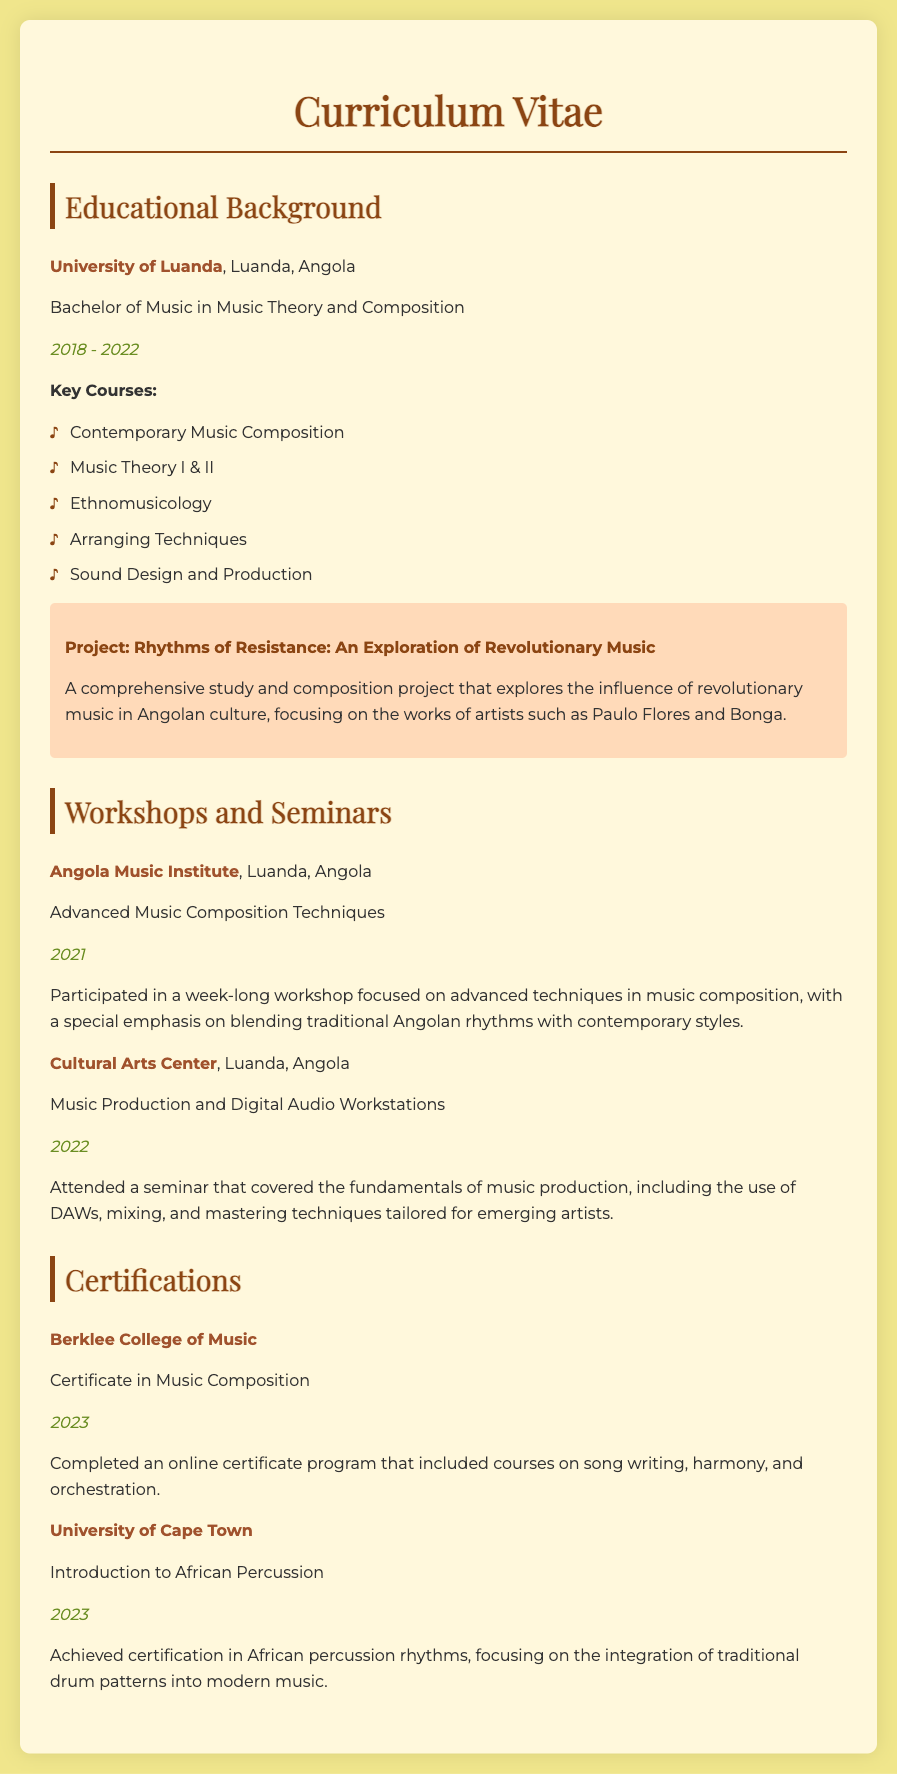What degree did you earn? The degree earned is stated in the "Educational Background" section as a Bachelor of Music in Music Theory and Composition.
Answer: Bachelor of Music in Music Theory and Composition Where did you study? The institution where the degree was obtained is mentioned as the University of Luanda, Luanda, Angola.
Answer: University of Luanda What years did you attend the university? The years of attendance are specified in the document as 2018 to 2022.
Answer: 2018 - 2022 What is a key course you took? The document lists several key courses, including Contemporary Music Composition, which is one of them.
Answer: Contemporary Music Composition What is the title of your project? The title of the project is clearly mentioned in the educational background section as "Rhythms of Resistance: An Exploration of Revolutionary Music."
Answer: Rhythms of Resistance: An Exploration of Revolutionary Music What certification did you receive from Berklee College of Music? The certification obtained is stated in the certifications section as a Certificate in Music Composition.
Answer: Certificate in Music Composition In what year did you complete your certification at the University of Cape Town? The year of completion for the certification is indicated as 2023 in the document.
Answer: 2023 What was the focus of the workshop at the Angola Music Institute? The focus of the workshop is described as advanced techniques in music composition with a special emphasis on blending traditional Angolan rhythms with contemporary styles.
Answer: Advanced techniques in music composition What institution hosted the seminar on music production? The institution that hosted the seminar is listed as the Cultural Arts Center in Luanda, Angola.
Answer: Cultural Arts Center 